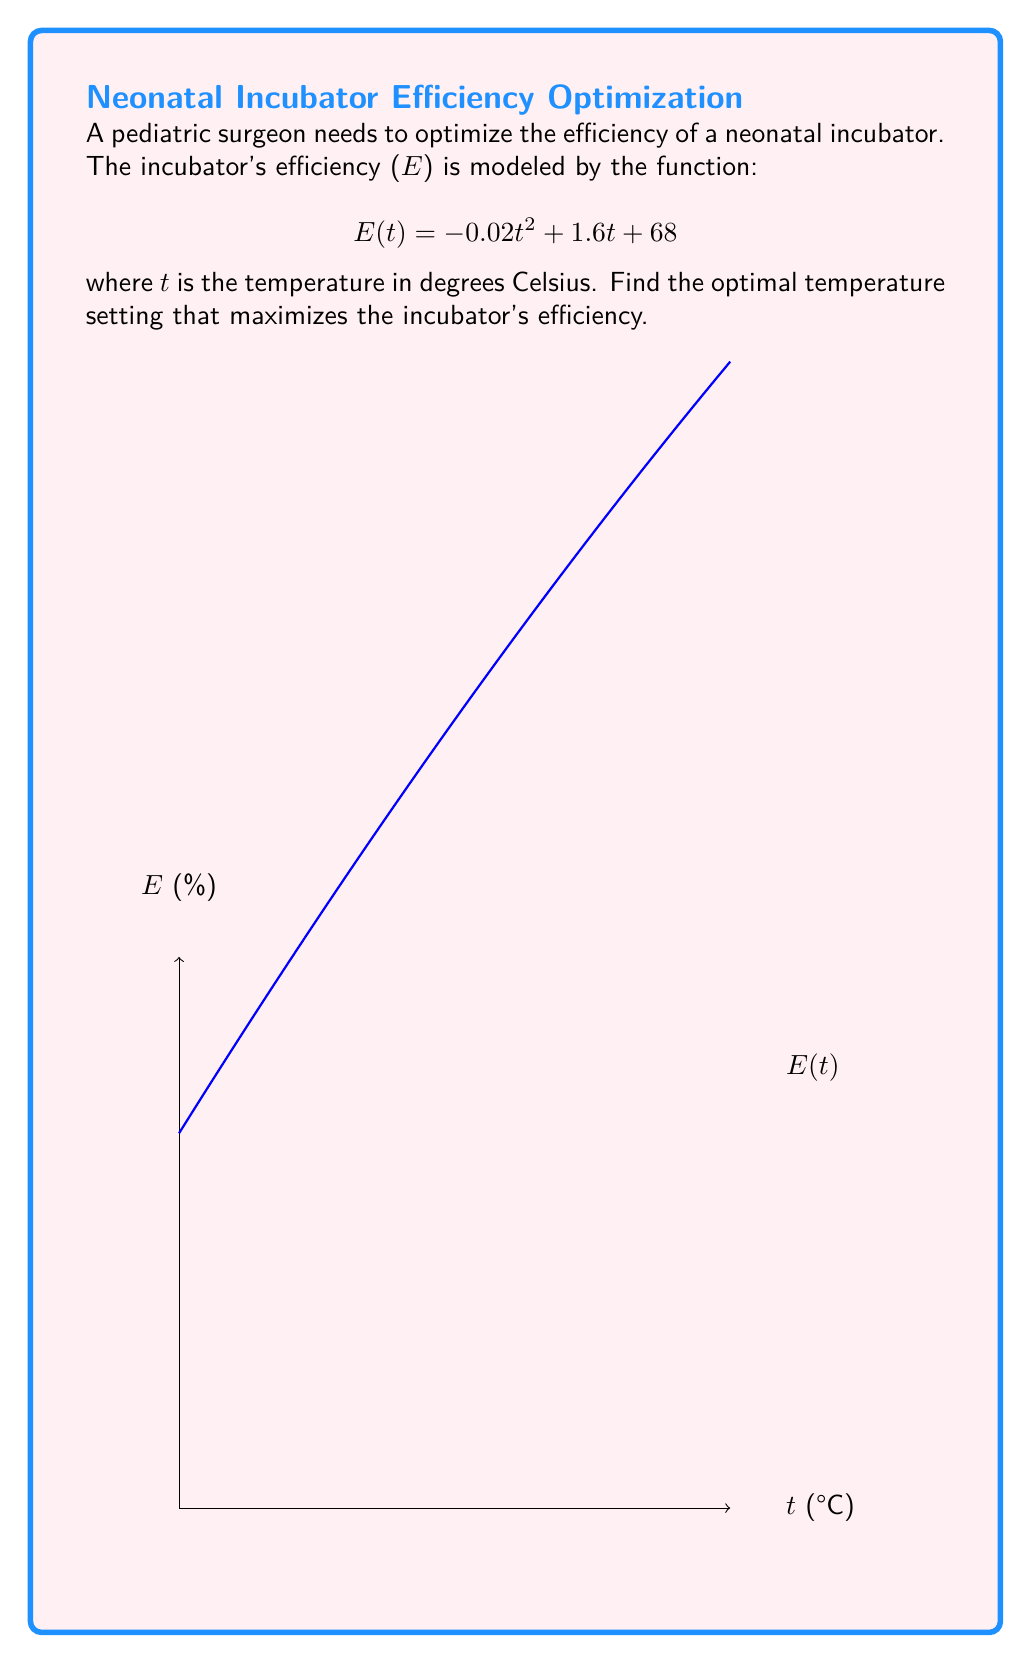Show me your answer to this math problem. To find the maximum efficiency, we need to find the vertex of the parabola described by $E(t)$. This can be done using calculus:

1) First, find the derivative of $E(t)$:
   $$E'(t) = -0.04t + 1.6$$

2) Set the derivative equal to zero to find the critical point:
   $$-0.04t + 1.6 = 0$$
   $$-0.04t = -1.6$$
   $$t = 40$$

3) Verify this is a maximum by checking the second derivative:
   $$E''(t) = -0.04$$
   Since $E''(t)$ is negative, the critical point is a maximum.

4) Calculate the maximum efficiency by plugging $t = 40$ into the original function:
   $$E(40) = -0.02(40)^2 + 1.6(40) + 68$$
   $$= -32 + 64 + 68 = 100$$

Therefore, the incubator's efficiency is maximized at a temperature of 40°C, achieving 100% efficiency.
Answer: 40°C 